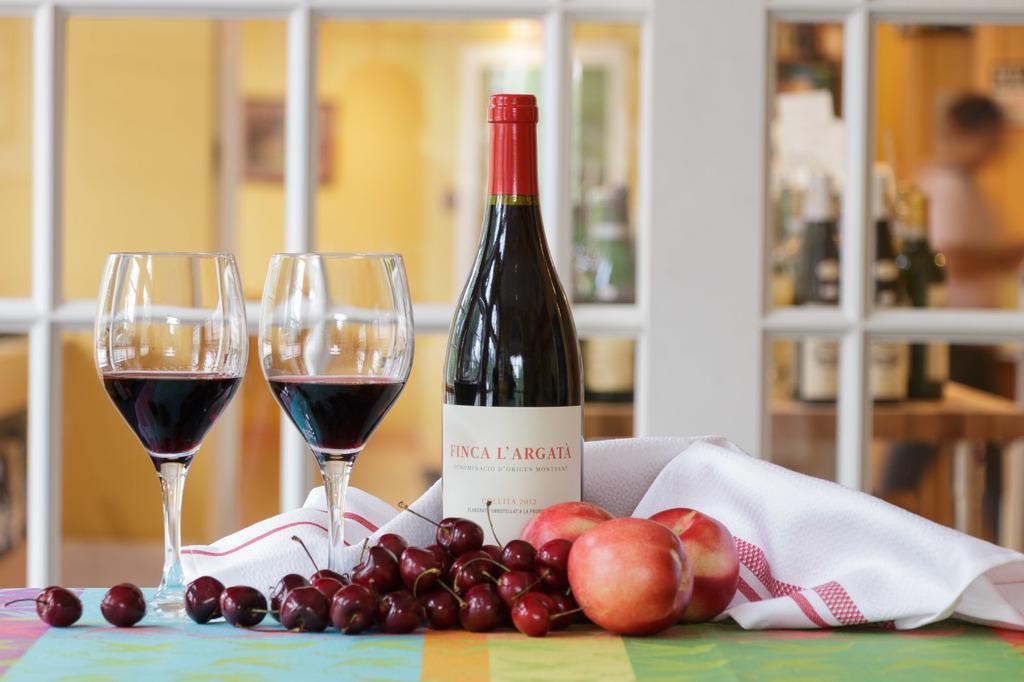In one or two sentences, can you explain what this image depicts? In the foreground of this picture, there is a table on which apples, cherries, two glasses, a bottle and a cloth is placed on it. In the background, we can see a glass door and through which bottles, a man, wall and a photo frame is seen. 